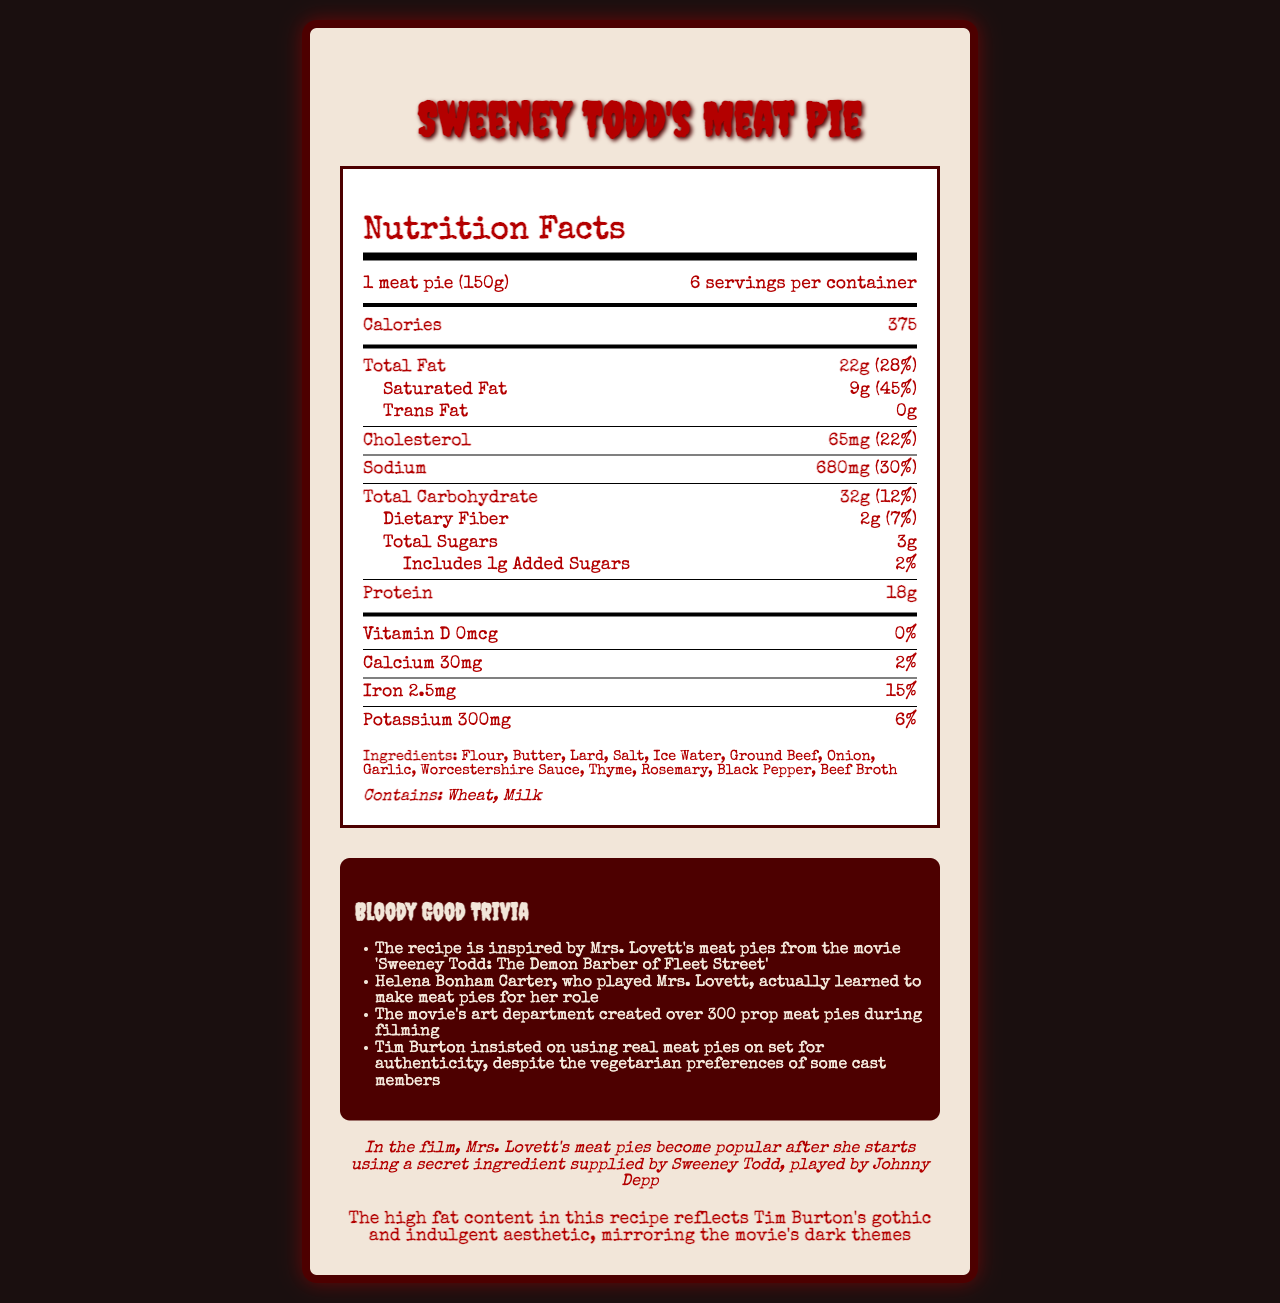what is the serving size for a single meat pie? The serving size is specified at the top of the nutrition facts label under "serving size".
Answer: 1 meat pie (150g) how many calories are in one serving of the meat pie? The number of calories per serving is listed directly under the serving size information.
Answer: 375 what is the total fat content in one serving, and what percentage of the daily value does it represent? The total fat content and its percentage of the daily value are specified under the "Total Fat" section of the nutrition label.
Answer: 22g, 28% how much sodium does each serving of the meat pie contain, and what percentage of the daily value does this represent? The sodium content and its daily value percentage are listed under the "Sodium" section of the nutrition label.
Answer: 680mg, 30% what is the total carbohydrate content per serving? The total carbohydrate content can be found under the "Total Carbohydrate" section of the nutrition label.
Answer: 32g (12%) How many grams of saturated fat are in each serving of the meat pie? The saturated fat content per serving is listed under the "Saturated Fat" section.
Answer: 9g Does the meat pie contain any trans fat? The document lists "0g" under the "Trans Fat" section.
Answer: No what are the allergies noted on the nutrition label for the meat pie? The allergens are labeled at the bottom of the nutrition facts box.
Answer: Wheat and Milk who learned to make meat pies for their role in 'Sweeney Todd'? This information is part of the trivia section under "Bloody Good Trivia".
Answer: Helena Bonham Carter what is the connection of this recipe to the movie 'Sweeney Todd'? This information is provided in the movie connection section.
Answer: Mrs. Lovett's meat pies become popular after she starts using a secret ingredient supplied by Sweeney Todd which of the following is NOT an ingredient in the meat pie recipe from the movie's cookbook?
A. Beef Broth
B. Garlic
C. Chicken Stock
D. Onion Chicken Stock is not listed under the ingredients section.
Answer: C. Chicken Stock How many servings are there per container of meat pies? 
1. 4 
2. 6 
3. 8 
4. 10 The number of servings per container is specified at the top of the nutrition facts label.
Answer: 2. 6 Is there any vitamin D in the meat pie recipe? The nutrition label shows 0mcg and 0% daily value for Vitamin D.
Answer: No Summarize the key nutritional content and unique features of the official "Sweeney Todd" meat pie recipe. The document contains a detailed nutrition label showing calories, fats, cholesterol, sodium, carbohydrates, and proteins per serving. It also highlights ingredients and allergens (wheat and milk). Additionally, trivia and movie connection sections underscore the connection to "Sweeney Todd," with particular notes like Helena Bonham Carter learning to make pies for her role, while also referencing the higher fat content reflecting Burton's aesthetic.
Answer: This meat pie recipe provides detailed nutritional content per serving, with 375 calories, high fat content including 22g of total fat and 9g of saturated fat, and significant levels of sodium (680mg). The ingredients include various common culinary items like flour, ground beef, and spices. There are also specific TV/movie buffs' trivia connecting the recipe to Tim Burton’s "Sweeney Todd" movie, emphasizing its gothic aesthetic. Does the meat pie recipe contain added sugars? If yes, how much? The nutrition label lists 1g of added sugars and a 2% daily value.
Answer: Yes, 1g What was the materials and code used to generate the document? The detailed code and materials used to generate the document are not visible within the rendered nutrition facts label.
Answer: Cannot be determined 